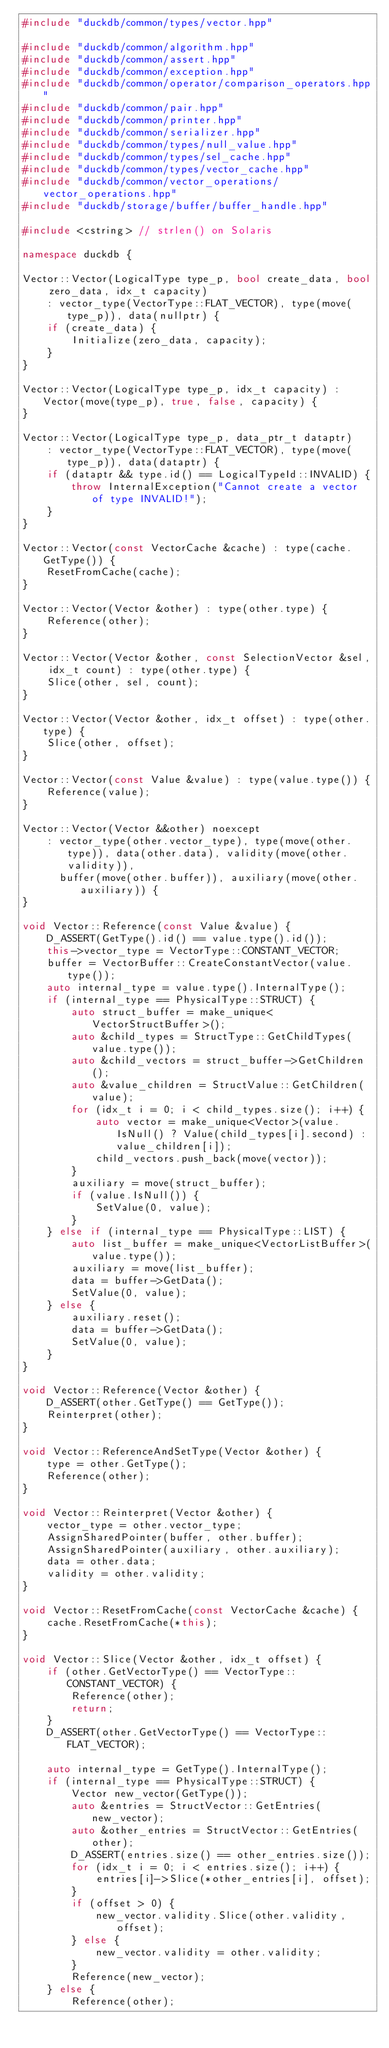<code> <loc_0><loc_0><loc_500><loc_500><_C++_>#include "duckdb/common/types/vector.hpp"

#include "duckdb/common/algorithm.hpp"
#include "duckdb/common/assert.hpp"
#include "duckdb/common/exception.hpp"
#include "duckdb/common/operator/comparison_operators.hpp"
#include "duckdb/common/pair.hpp"
#include "duckdb/common/printer.hpp"
#include "duckdb/common/serializer.hpp"
#include "duckdb/common/types/null_value.hpp"
#include "duckdb/common/types/sel_cache.hpp"
#include "duckdb/common/types/vector_cache.hpp"
#include "duckdb/common/vector_operations/vector_operations.hpp"
#include "duckdb/storage/buffer/buffer_handle.hpp"

#include <cstring> // strlen() on Solaris

namespace duckdb {

Vector::Vector(LogicalType type_p, bool create_data, bool zero_data, idx_t capacity)
    : vector_type(VectorType::FLAT_VECTOR), type(move(type_p)), data(nullptr) {
	if (create_data) {
		Initialize(zero_data, capacity);
	}
}

Vector::Vector(LogicalType type_p, idx_t capacity) : Vector(move(type_p), true, false, capacity) {
}

Vector::Vector(LogicalType type_p, data_ptr_t dataptr)
    : vector_type(VectorType::FLAT_VECTOR), type(move(type_p)), data(dataptr) {
	if (dataptr && type.id() == LogicalTypeId::INVALID) {
		throw InternalException("Cannot create a vector of type INVALID!");
	}
}

Vector::Vector(const VectorCache &cache) : type(cache.GetType()) {
	ResetFromCache(cache);
}

Vector::Vector(Vector &other) : type(other.type) {
	Reference(other);
}

Vector::Vector(Vector &other, const SelectionVector &sel, idx_t count) : type(other.type) {
	Slice(other, sel, count);
}

Vector::Vector(Vector &other, idx_t offset) : type(other.type) {
	Slice(other, offset);
}

Vector::Vector(const Value &value) : type(value.type()) {
	Reference(value);
}

Vector::Vector(Vector &&other) noexcept
    : vector_type(other.vector_type), type(move(other.type)), data(other.data), validity(move(other.validity)),
      buffer(move(other.buffer)), auxiliary(move(other.auxiliary)) {
}

void Vector::Reference(const Value &value) {
	D_ASSERT(GetType().id() == value.type().id());
	this->vector_type = VectorType::CONSTANT_VECTOR;
	buffer = VectorBuffer::CreateConstantVector(value.type());
	auto internal_type = value.type().InternalType();
	if (internal_type == PhysicalType::STRUCT) {
		auto struct_buffer = make_unique<VectorStructBuffer>();
		auto &child_types = StructType::GetChildTypes(value.type());
		auto &child_vectors = struct_buffer->GetChildren();
		auto &value_children = StructValue::GetChildren(value);
		for (idx_t i = 0; i < child_types.size(); i++) {
			auto vector = make_unique<Vector>(value.IsNull() ? Value(child_types[i].second) : value_children[i]);
			child_vectors.push_back(move(vector));
		}
		auxiliary = move(struct_buffer);
		if (value.IsNull()) {
			SetValue(0, value);
		}
	} else if (internal_type == PhysicalType::LIST) {
		auto list_buffer = make_unique<VectorListBuffer>(value.type());
		auxiliary = move(list_buffer);
		data = buffer->GetData();
		SetValue(0, value);
	} else {
		auxiliary.reset();
		data = buffer->GetData();
		SetValue(0, value);
	}
}

void Vector::Reference(Vector &other) {
	D_ASSERT(other.GetType() == GetType());
	Reinterpret(other);
}

void Vector::ReferenceAndSetType(Vector &other) {
	type = other.GetType();
	Reference(other);
}

void Vector::Reinterpret(Vector &other) {
	vector_type = other.vector_type;
	AssignSharedPointer(buffer, other.buffer);
	AssignSharedPointer(auxiliary, other.auxiliary);
	data = other.data;
	validity = other.validity;
}

void Vector::ResetFromCache(const VectorCache &cache) {
	cache.ResetFromCache(*this);
}

void Vector::Slice(Vector &other, idx_t offset) {
	if (other.GetVectorType() == VectorType::CONSTANT_VECTOR) {
		Reference(other);
		return;
	}
	D_ASSERT(other.GetVectorType() == VectorType::FLAT_VECTOR);

	auto internal_type = GetType().InternalType();
	if (internal_type == PhysicalType::STRUCT) {
		Vector new_vector(GetType());
		auto &entries = StructVector::GetEntries(new_vector);
		auto &other_entries = StructVector::GetEntries(other);
		D_ASSERT(entries.size() == other_entries.size());
		for (idx_t i = 0; i < entries.size(); i++) {
			entries[i]->Slice(*other_entries[i], offset);
		}
		if (offset > 0) {
			new_vector.validity.Slice(other.validity, offset);
		} else {
			new_vector.validity = other.validity;
		}
		Reference(new_vector);
	} else {
		Reference(other);</code> 